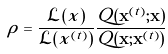Convert formula to latex. <formula><loc_0><loc_0><loc_500><loc_500>\rho = \frac { { \mathcal { L } } ( { x } ) } { { \mathcal { L } } { ( { x } ^ { ( t ) } ) } } \frac { Q ( { \mathbf x } ^ { ( t ) } ; { \mathbf x } ) } { Q ( { \mathbf x } ; { \mathbf x } ^ { ( t ) } ) }</formula> 